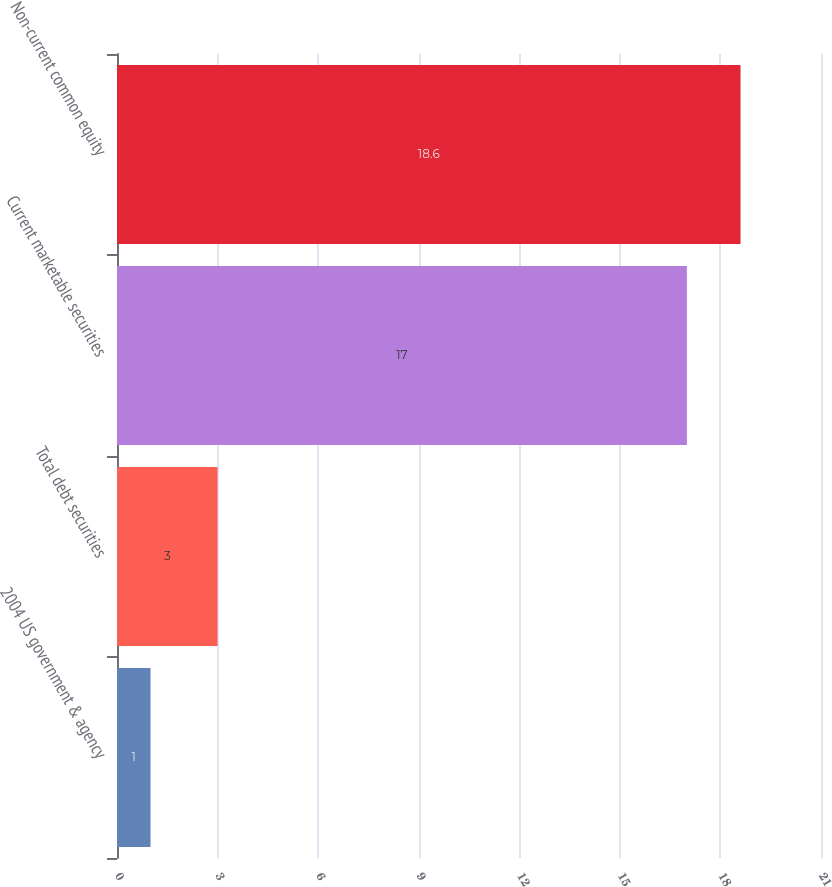<chart> <loc_0><loc_0><loc_500><loc_500><bar_chart><fcel>2004 US government & agency<fcel>Total debt securities<fcel>Current marketable securities<fcel>Non-current common equity<nl><fcel>1<fcel>3<fcel>17<fcel>18.6<nl></chart> 